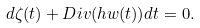<formula> <loc_0><loc_0><loc_500><loc_500>d \zeta ( t ) + D i v ( h w ( t ) ) d t = 0 .</formula> 